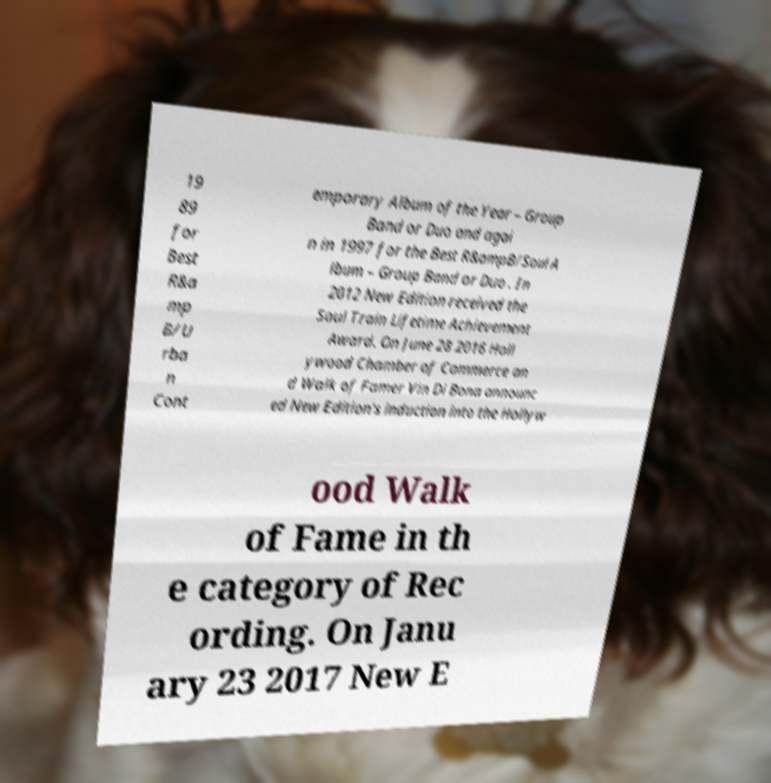There's text embedded in this image that I need extracted. Can you transcribe it verbatim? 19 89 for Best R&a mp B/U rba n Cont emporary Album of the Year – Group Band or Duo and agai n in 1997 for the Best R&ampB/Soul A lbum – Group Band or Duo . In 2012 New Edition received the Soul Train Lifetime Achievement Award. On June 28 2016 Holl ywood Chamber of Commerce an d Walk of Famer Vin Di Bona announc ed New Edition's induction into the Hollyw ood Walk of Fame in th e category of Rec ording. On Janu ary 23 2017 New E 